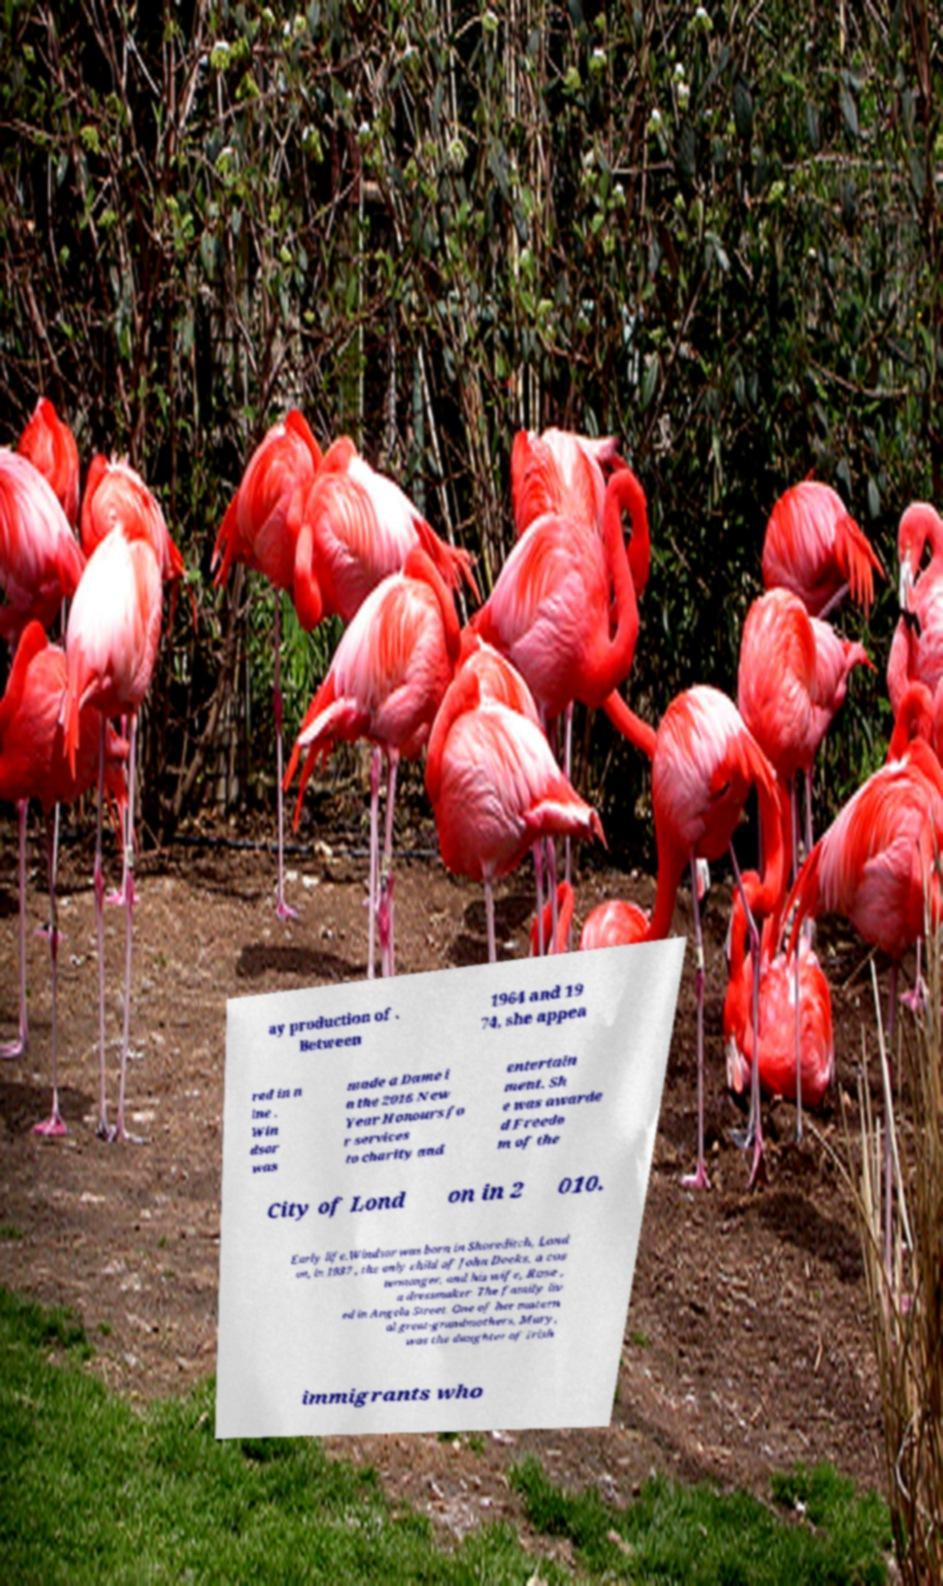Could you assist in decoding the text presented in this image and type it out clearly? ay production of . Between 1964 and 19 74, she appea red in n ine . Win dsor was made a Dame i n the 2016 New Year Honours fo r services to charity and entertain ment. Sh e was awarde d Freedo m of the City of Lond on in 2 010. Early life.Windsor was born in Shoreditch, Lond on, in 1937 , the only child of John Deeks, a cos termonger, and his wife, Rose , a dressmaker. The family liv ed in Angela Street. One of her matern al great-grandmothers, Mary, was the daughter of Irish immigrants who 